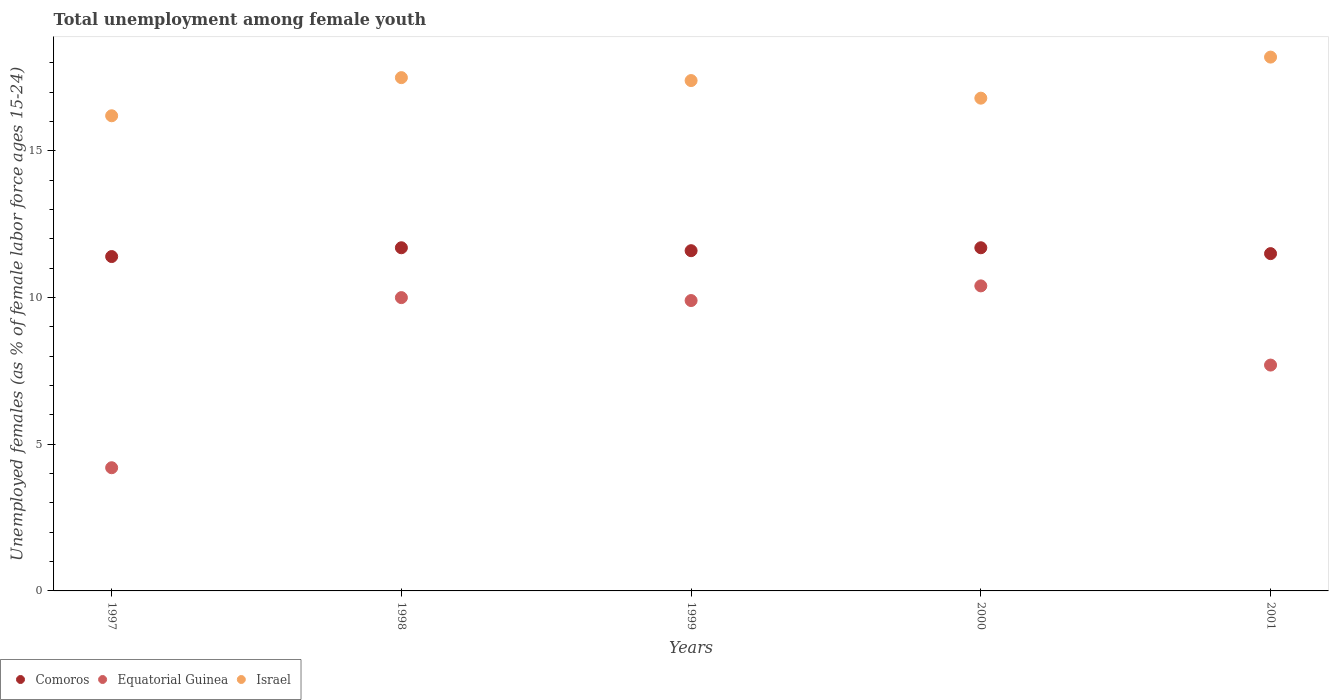Is the number of dotlines equal to the number of legend labels?
Provide a succinct answer. Yes. What is the percentage of unemployed females in in Israel in 2001?
Make the answer very short. 18.2. Across all years, what is the maximum percentage of unemployed females in in Equatorial Guinea?
Your answer should be very brief. 10.4. Across all years, what is the minimum percentage of unemployed females in in Israel?
Ensure brevity in your answer.  16.2. In which year was the percentage of unemployed females in in Comoros minimum?
Give a very brief answer. 1997. What is the total percentage of unemployed females in in Equatorial Guinea in the graph?
Give a very brief answer. 42.2. What is the difference between the percentage of unemployed females in in Comoros in 1999 and that in 2001?
Offer a terse response. 0.1. What is the difference between the percentage of unemployed females in in Comoros in 1998 and the percentage of unemployed females in in Israel in 2001?
Make the answer very short. -6.5. What is the average percentage of unemployed females in in Equatorial Guinea per year?
Offer a terse response. 8.44. In the year 1999, what is the difference between the percentage of unemployed females in in Equatorial Guinea and percentage of unemployed females in in Comoros?
Your response must be concise. -1.7. What is the ratio of the percentage of unemployed females in in Equatorial Guinea in 2000 to that in 2001?
Make the answer very short. 1.35. Is the percentage of unemployed females in in Equatorial Guinea in 1997 less than that in 1998?
Provide a succinct answer. Yes. Is the difference between the percentage of unemployed females in in Equatorial Guinea in 1999 and 2000 greater than the difference between the percentage of unemployed females in in Comoros in 1999 and 2000?
Provide a succinct answer. No. What is the difference between the highest and the lowest percentage of unemployed females in in Equatorial Guinea?
Your answer should be compact. 6.2. Is the sum of the percentage of unemployed females in in Israel in 1999 and 2000 greater than the maximum percentage of unemployed females in in Equatorial Guinea across all years?
Keep it short and to the point. Yes. Does the percentage of unemployed females in in Equatorial Guinea monotonically increase over the years?
Provide a short and direct response. No. Is the percentage of unemployed females in in Equatorial Guinea strictly greater than the percentage of unemployed females in in Comoros over the years?
Offer a terse response. No. Is the percentage of unemployed females in in Israel strictly less than the percentage of unemployed females in in Comoros over the years?
Ensure brevity in your answer.  No. How many dotlines are there?
Keep it short and to the point. 3. How many years are there in the graph?
Provide a succinct answer. 5. What is the difference between two consecutive major ticks on the Y-axis?
Provide a short and direct response. 5. Are the values on the major ticks of Y-axis written in scientific E-notation?
Keep it short and to the point. No. Does the graph contain any zero values?
Offer a very short reply. No. Does the graph contain grids?
Offer a terse response. No. How are the legend labels stacked?
Give a very brief answer. Horizontal. What is the title of the graph?
Your answer should be compact. Total unemployment among female youth. Does "Bulgaria" appear as one of the legend labels in the graph?
Provide a short and direct response. No. What is the label or title of the Y-axis?
Your answer should be compact. Unemployed females (as % of female labor force ages 15-24). What is the Unemployed females (as % of female labor force ages 15-24) of Comoros in 1997?
Provide a succinct answer. 11.4. What is the Unemployed females (as % of female labor force ages 15-24) in Equatorial Guinea in 1997?
Your response must be concise. 4.2. What is the Unemployed females (as % of female labor force ages 15-24) in Israel in 1997?
Give a very brief answer. 16.2. What is the Unemployed females (as % of female labor force ages 15-24) of Comoros in 1998?
Offer a terse response. 11.7. What is the Unemployed females (as % of female labor force ages 15-24) of Comoros in 1999?
Make the answer very short. 11.6. What is the Unemployed females (as % of female labor force ages 15-24) of Equatorial Guinea in 1999?
Offer a very short reply. 9.9. What is the Unemployed females (as % of female labor force ages 15-24) of Israel in 1999?
Provide a short and direct response. 17.4. What is the Unemployed females (as % of female labor force ages 15-24) of Comoros in 2000?
Provide a short and direct response. 11.7. What is the Unemployed females (as % of female labor force ages 15-24) in Equatorial Guinea in 2000?
Keep it short and to the point. 10.4. What is the Unemployed females (as % of female labor force ages 15-24) of Israel in 2000?
Provide a short and direct response. 16.8. What is the Unemployed females (as % of female labor force ages 15-24) in Comoros in 2001?
Give a very brief answer. 11.5. What is the Unemployed females (as % of female labor force ages 15-24) in Equatorial Guinea in 2001?
Provide a succinct answer. 7.7. What is the Unemployed females (as % of female labor force ages 15-24) in Israel in 2001?
Provide a short and direct response. 18.2. Across all years, what is the maximum Unemployed females (as % of female labor force ages 15-24) of Comoros?
Ensure brevity in your answer.  11.7. Across all years, what is the maximum Unemployed females (as % of female labor force ages 15-24) of Equatorial Guinea?
Your answer should be compact. 10.4. Across all years, what is the maximum Unemployed females (as % of female labor force ages 15-24) of Israel?
Provide a short and direct response. 18.2. Across all years, what is the minimum Unemployed females (as % of female labor force ages 15-24) of Comoros?
Give a very brief answer. 11.4. Across all years, what is the minimum Unemployed females (as % of female labor force ages 15-24) in Equatorial Guinea?
Offer a terse response. 4.2. Across all years, what is the minimum Unemployed females (as % of female labor force ages 15-24) in Israel?
Your response must be concise. 16.2. What is the total Unemployed females (as % of female labor force ages 15-24) of Comoros in the graph?
Make the answer very short. 57.9. What is the total Unemployed females (as % of female labor force ages 15-24) in Equatorial Guinea in the graph?
Your answer should be very brief. 42.2. What is the total Unemployed females (as % of female labor force ages 15-24) in Israel in the graph?
Your answer should be compact. 86.1. What is the difference between the Unemployed females (as % of female labor force ages 15-24) of Comoros in 1997 and that in 1998?
Offer a terse response. -0.3. What is the difference between the Unemployed females (as % of female labor force ages 15-24) in Comoros in 1997 and that in 1999?
Make the answer very short. -0.2. What is the difference between the Unemployed females (as % of female labor force ages 15-24) in Comoros in 1997 and that in 2000?
Your answer should be compact. -0.3. What is the difference between the Unemployed females (as % of female labor force ages 15-24) of Equatorial Guinea in 1997 and that in 2000?
Offer a very short reply. -6.2. What is the difference between the Unemployed females (as % of female labor force ages 15-24) in Comoros in 1997 and that in 2001?
Your answer should be very brief. -0.1. What is the difference between the Unemployed females (as % of female labor force ages 15-24) in Equatorial Guinea in 1998 and that in 1999?
Keep it short and to the point. 0.1. What is the difference between the Unemployed females (as % of female labor force ages 15-24) in Israel in 1998 and that in 1999?
Ensure brevity in your answer.  0.1. What is the difference between the Unemployed females (as % of female labor force ages 15-24) of Comoros in 1998 and that in 2000?
Offer a very short reply. 0. What is the difference between the Unemployed females (as % of female labor force ages 15-24) in Comoros in 1998 and that in 2001?
Your response must be concise. 0.2. What is the difference between the Unemployed females (as % of female labor force ages 15-24) of Equatorial Guinea in 1998 and that in 2001?
Offer a terse response. 2.3. What is the difference between the Unemployed females (as % of female labor force ages 15-24) of Comoros in 1999 and that in 2000?
Offer a very short reply. -0.1. What is the difference between the Unemployed females (as % of female labor force ages 15-24) of Equatorial Guinea in 1999 and that in 2000?
Offer a very short reply. -0.5. What is the difference between the Unemployed females (as % of female labor force ages 15-24) of Comoros in 1999 and that in 2001?
Offer a terse response. 0.1. What is the difference between the Unemployed females (as % of female labor force ages 15-24) in Equatorial Guinea in 1999 and that in 2001?
Give a very brief answer. 2.2. What is the difference between the Unemployed females (as % of female labor force ages 15-24) of Israel in 1999 and that in 2001?
Keep it short and to the point. -0.8. What is the difference between the Unemployed females (as % of female labor force ages 15-24) of Comoros in 2000 and that in 2001?
Offer a terse response. 0.2. What is the difference between the Unemployed females (as % of female labor force ages 15-24) in Equatorial Guinea in 2000 and that in 2001?
Your answer should be compact. 2.7. What is the difference between the Unemployed females (as % of female labor force ages 15-24) in Israel in 2000 and that in 2001?
Make the answer very short. -1.4. What is the difference between the Unemployed females (as % of female labor force ages 15-24) in Equatorial Guinea in 1997 and the Unemployed females (as % of female labor force ages 15-24) in Israel in 1998?
Your answer should be very brief. -13.3. What is the difference between the Unemployed females (as % of female labor force ages 15-24) of Comoros in 1997 and the Unemployed females (as % of female labor force ages 15-24) of Equatorial Guinea in 1999?
Your answer should be very brief. 1.5. What is the difference between the Unemployed females (as % of female labor force ages 15-24) in Comoros in 1997 and the Unemployed females (as % of female labor force ages 15-24) in Israel in 2000?
Your response must be concise. -5.4. What is the difference between the Unemployed females (as % of female labor force ages 15-24) of Equatorial Guinea in 1997 and the Unemployed females (as % of female labor force ages 15-24) of Israel in 2000?
Keep it short and to the point. -12.6. What is the difference between the Unemployed females (as % of female labor force ages 15-24) in Comoros in 1997 and the Unemployed females (as % of female labor force ages 15-24) in Israel in 2001?
Make the answer very short. -6.8. What is the difference between the Unemployed females (as % of female labor force ages 15-24) in Comoros in 1998 and the Unemployed females (as % of female labor force ages 15-24) in Equatorial Guinea in 1999?
Your answer should be compact. 1.8. What is the difference between the Unemployed females (as % of female labor force ages 15-24) of Comoros in 1998 and the Unemployed females (as % of female labor force ages 15-24) of Israel in 1999?
Make the answer very short. -5.7. What is the difference between the Unemployed females (as % of female labor force ages 15-24) of Equatorial Guinea in 1998 and the Unemployed females (as % of female labor force ages 15-24) of Israel in 1999?
Keep it short and to the point. -7.4. What is the difference between the Unemployed females (as % of female labor force ages 15-24) in Comoros in 1998 and the Unemployed females (as % of female labor force ages 15-24) in Equatorial Guinea in 2000?
Your answer should be very brief. 1.3. What is the difference between the Unemployed females (as % of female labor force ages 15-24) of Comoros in 1998 and the Unemployed females (as % of female labor force ages 15-24) of Israel in 2000?
Keep it short and to the point. -5.1. What is the difference between the Unemployed females (as % of female labor force ages 15-24) in Comoros in 1999 and the Unemployed females (as % of female labor force ages 15-24) in Equatorial Guinea in 2000?
Your answer should be compact. 1.2. What is the difference between the Unemployed females (as % of female labor force ages 15-24) in Comoros in 1999 and the Unemployed females (as % of female labor force ages 15-24) in Israel in 2000?
Your answer should be very brief. -5.2. What is the difference between the Unemployed females (as % of female labor force ages 15-24) in Comoros in 1999 and the Unemployed females (as % of female labor force ages 15-24) in Equatorial Guinea in 2001?
Keep it short and to the point. 3.9. What is the difference between the Unemployed females (as % of female labor force ages 15-24) in Equatorial Guinea in 1999 and the Unemployed females (as % of female labor force ages 15-24) in Israel in 2001?
Provide a succinct answer. -8.3. What is the difference between the Unemployed females (as % of female labor force ages 15-24) in Comoros in 2000 and the Unemployed females (as % of female labor force ages 15-24) in Equatorial Guinea in 2001?
Ensure brevity in your answer.  4. What is the average Unemployed females (as % of female labor force ages 15-24) of Comoros per year?
Make the answer very short. 11.58. What is the average Unemployed females (as % of female labor force ages 15-24) in Equatorial Guinea per year?
Make the answer very short. 8.44. What is the average Unemployed females (as % of female labor force ages 15-24) of Israel per year?
Keep it short and to the point. 17.22. In the year 1997, what is the difference between the Unemployed females (as % of female labor force ages 15-24) of Comoros and Unemployed females (as % of female labor force ages 15-24) of Equatorial Guinea?
Offer a very short reply. 7.2. In the year 1997, what is the difference between the Unemployed females (as % of female labor force ages 15-24) of Comoros and Unemployed females (as % of female labor force ages 15-24) of Israel?
Make the answer very short. -4.8. In the year 1998, what is the difference between the Unemployed females (as % of female labor force ages 15-24) in Comoros and Unemployed females (as % of female labor force ages 15-24) in Israel?
Offer a very short reply. -5.8. In the year 1998, what is the difference between the Unemployed females (as % of female labor force ages 15-24) in Equatorial Guinea and Unemployed females (as % of female labor force ages 15-24) in Israel?
Offer a terse response. -7.5. In the year 1999, what is the difference between the Unemployed females (as % of female labor force ages 15-24) of Comoros and Unemployed females (as % of female labor force ages 15-24) of Equatorial Guinea?
Keep it short and to the point. 1.7. In the year 1999, what is the difference between the Unemployed females (as % of female labor force ages 15-24) in Comoros and Unemployed females (as % of female labor force ages 15-24) in Israel?
Make the answer very short. -5.8. In the year 1999, what is the difference between the Unemployed females (as % of female labor force ages 15-24) of Equatorial Guinea and Unemployed females (as % of female labor force ages 15-24) of Israel?
Your response must be concise. -7.5. In the year 2000, what is the difference between the Unemployed females (as % of female labor force ages 15-24) of Comoros and Unemployed females (as % of female labor force ages 15-24) of Israel?
Your answer should be very brief. -5.1. In the year 2001, what is the difference between the Unemployed females (as % of female labor force ages 15-24) in Equatorial Guinea and Unemployed females (as % of female labor force ages 15-24) in Israel?
Offer a terse response. -10.5. What is the ratio of the Unemployed females (as % of female labor force ages 15-24) in Comoros in 1997 to that in 1998?
Offer a terse response. 0.97. What is the ratio of the Unemployed females (as % of female labor force ages 15-24) of Equatorial Guinea in 1997 to that in 1998?
Keep it short and to the point. 0.42. What is the ratio of the Unemployed females (as % of female labor force ages 15-24) of Israel in 1997 to that in 1998?
Offer a very short reply. 0.93. What is the ratio of the Unemployed females (as % of female labor force ages 15-24) in Comoros in 1997 to that in 1999?
Your response must be concise. 0.98. What is the ratio of the Unemployed females (as % of female labor force ages 15-24) in Equatorial Guinea in 1997 to that in 1999?
Your response must be concise. 0.42. What is the ratio of the Unemployed females (as % of female labor force ages 15-24) of Israel in 1997 to that in 1999?
Keep it short and to the point. 0.93. What is the ratio of the Unemployed females (as % of female labor force ages 15-24) of Comoros in 1997 to that in 2000?
Make the answer very short. 0.97. What is the ratio of the Unemployed females (as % of female labor force ages 15-24) of Equatorial Guinea in 1997 to that in 2000?
Your answer should be very brief. 0.4. What is the ratio of the Unemployed females (as % of female labor force ages 15-24) of Comoros in 1997 to that in 2001?
Your response must be concise. 0.99. What is the ratio of the Unemployed females (as % of female labor force ages 15-24) in Equatorial Guinea in 1997 to that in 2001?
Offer a very short reply. 0.55. What is the ratio of the Unemployed females (as % of female labor force ages 15-24) in Israel in 1997 to that in 2001?
Offer a very short reply. 0.89. What is the ratio of the Unemployed females (as % of female labor force ages 15-24) of Comoros in 1998 to that in 1999?
Keep it short and to the point. 1.01. What is the ratio of the Unemployed females (as % of female labor force ages 15-24) in Equatorial Guinea in 1998 to that in 1999?
Ensure brevity in your answer.  1.01. What is the ratio of the Unemployed females (as % of female labor force ages 15-24) of Israel in 1998 to that in 1999?
Your answer should be compact. 1.01. What is the ratio of the Unemployed females (as % of female labor force ages 15-24) of Equatorial Guinea in 1998 to that in 2000?
Keep it short and to the point. 0.96. What is the ratio of the Unemployed females (as % of female labor force ages 15-24) of Israel in 1998 to that in 2000?
Your response must be concise. 1.04. What is the ratio of the Unemployed females (as % of female labor force ages 15-24) of Comoros in 1998 to that in 2001?
Your response must be concise. 1.02. What is the ratio of the Unemployed females (as % of female labor force ages 15-24) of Equatorial Guinea in 1998 to that in 2001?
Offer a very short reply. 1.3. What is the ratio of the Unemployed females (as % of female labor force ages 15-24) in Israel in 1998 to that in 2001?
Keep it short and to the point. 0.96. What is the ratio of the Unemployed females (as % of female labor force ages 15-24) in Comoros in 1999 to that in 2000?
Your answer should be very brief. 0.99. What is the ratio of the Unemployed females (as % of female labor force ages 15-24) in Equatorial Guinea in 1999 to that in 2000?
Provide a short and direct response. 0.95. What is the ratio of the Unemployed females (as % of female labor force ages 15-24) of Israel in 1999 to that in 2000?
Provide a short and direct response. 1.04. What is the ratio of the Unemployed females (as % of female labor force ages 15-24) in Comoros in 1999 to that in 2001?
Your answer should be compact. 1.01. What is the ratio of the Unemployed females (as % of female labor force ages 15-24) of Equatorial Guinea in 1999 to that in 2001?
Offer a terse response. 1.29. What is the ratio of the Unemployed females (as % of female labor force ages 15-24) in Israel in 1999 to that in 2001?
Provide a short and direct response. 0.96. What is the ratio of the Unemployed females (as % of female labor force ages 15-24) in Comoros in 2000 to that in 2001?
Make the answer very short. 1.02. What is the ratio of the Unemployed females (as % of female labor force ages 15-24) in Equatorial Guinea in 2000 to that in 2001?
Provide a short and direct response. 1.35. What is the difference between the highest and the second highest Unemployed females (as % of female labor force ages 15-24) of Comoros?
Give a very brief answer. 0. What is the difference between the highest and the lowest Unemployed females (as % of female labor force ages 15-24) in Comoros?
Ensure brevity in your answer.  0.3. What is the difference between the highest and the lowest Unemployed females (as % of female labor force ages 15-24) in Israel?
Provide a succinct answer. 2. 